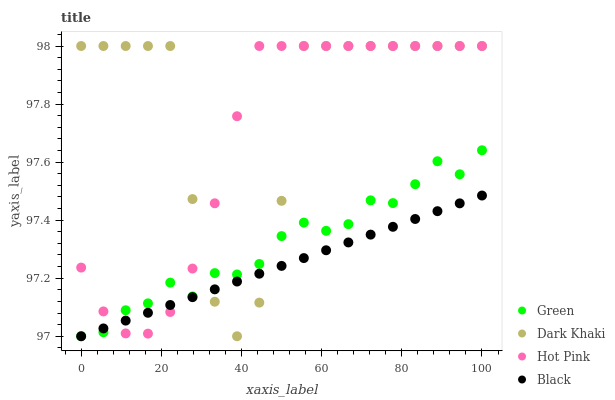Does Black have the minimum area under the curve?
Answer yes or no. Yes. Does Dark Khaki have the maximum area under the curve?
Answer yes or no. Yes. Does Hot Pink have the minimum area under the curve?
Answer yes or no. No. Does Hot Pink have the maximum area under the curve?
Answer yes or no. No. Is Black the smoothest?
Answer yes or no. Yes. Is Dark Khaki the roughest?
Answer yes or no. Yes. Is Hot Pink the smoothest?
Answer yes or no. No. Is Hot Pink the roughest?
Answer yes or no. No. Does Black have the lowest value?
Answer yes or no. Yes. Does Hot Pink have the lowest value?
Answer yes or no. No. Does Hot Pink have the highest value?
Answer yes or no. Yes. Does Black have the highest value?
Answer yes or no. No. Does Green intersect Black?
Answer yes or no. Yes. Is Green less than Black?
Answer yes or no. No. Is Green greater than Black?
Answer yes or no. No. 